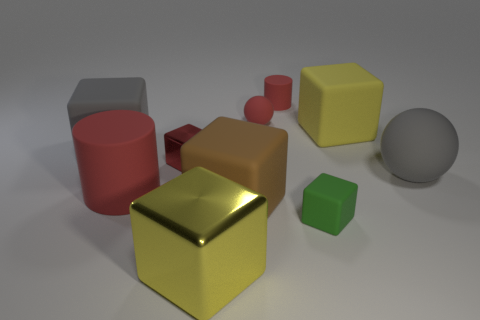There is a block that is both to the right of the small red sphere and in front of the big red matte object; what material is it?
Your answer should be very brief. Rubber. There is a metallic thing in front of the brown object; is it the same size as the small cylinder?
Keep it short and to the point. No. Are there any other things that have the same size as the green matte cube?
Your answer should be compact. Yes. Is the number of big red cylinders that are behind the large gray rubber block greater than the number of tiny green rubber objects behind the brown object?
Offer a very short reply. No. What color is the matte ball that is to the right of the sphere behind the matte ball that is in front of the big yellow matte cube?
Offer a terse response. Gray. Does the rubber cylinder that is in front of the big gray block have the same color as the small ball?
Make the answer very short. Yes. What number of other objects are there of the same color as the big cylinder?
Your answer should be very brief. 3. How many things are large spheres or large yellow metallic things?
Your answer should be very brief. 2. What number of things are either red metallic objects or big gray rubber things to the right of the small sphere?
Ensure brevity in your answer.  2. Do the big cylinder and the big gray ball have the same material?
Your answer should be compact. Yes. 